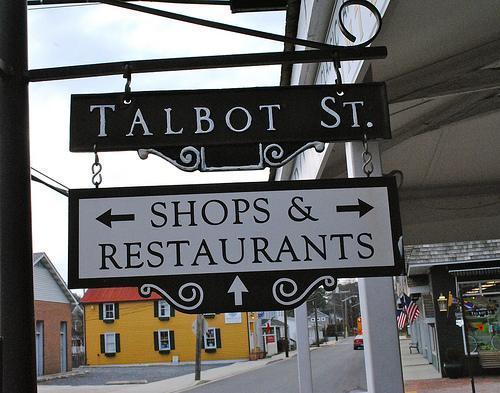How many signs are there?
Give a very brief answer. 2. How many windows are on the yellow building?
Give a very brief answer. 6. 